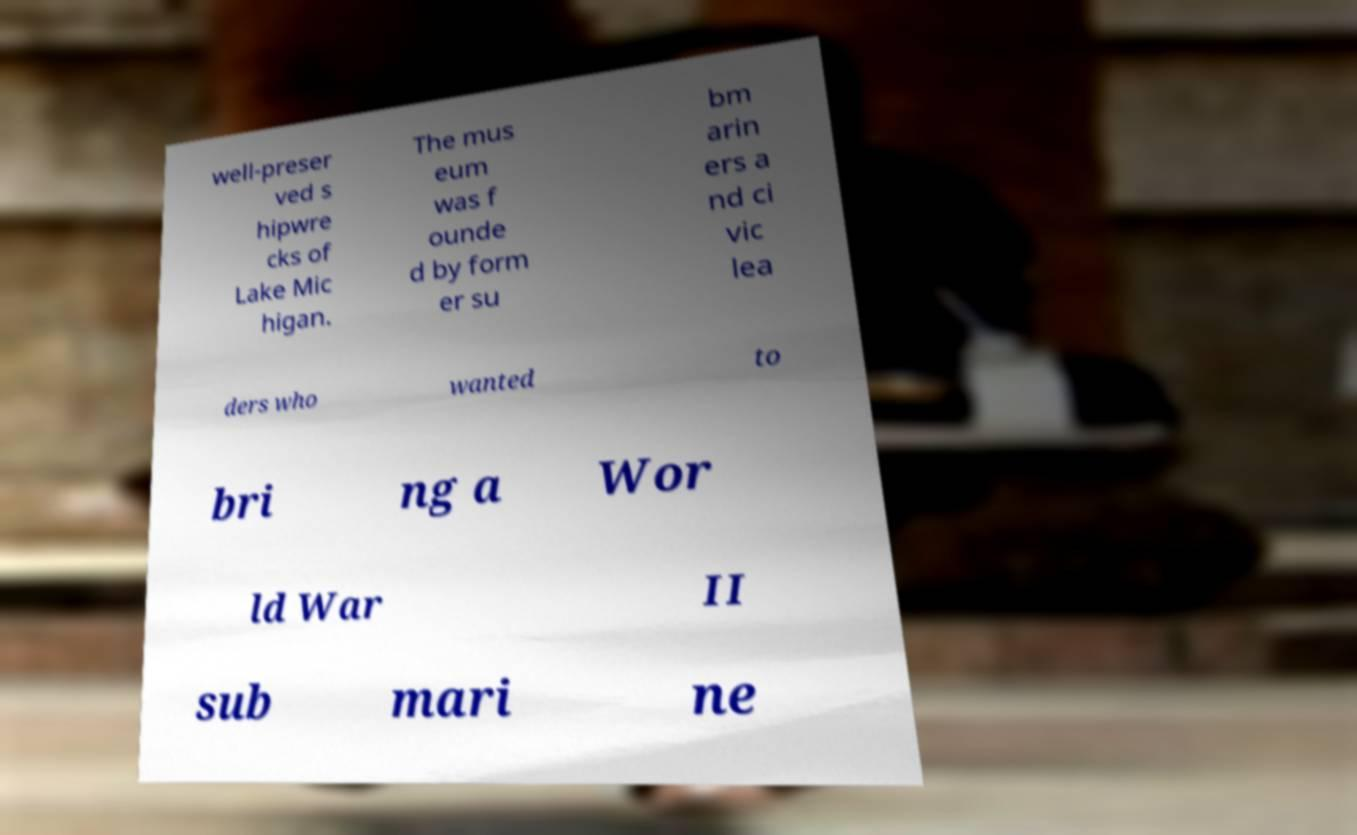For documentation purposes, I need the text within this image transcribed. Could you provide that? well-preser ved s hipwre cks of Lake Mic higan. The mus eum was f ounde d by form er su bm arin ers a nd ci vic lea ders who wanted to bri ng a Wor ld War II sub mari ne 